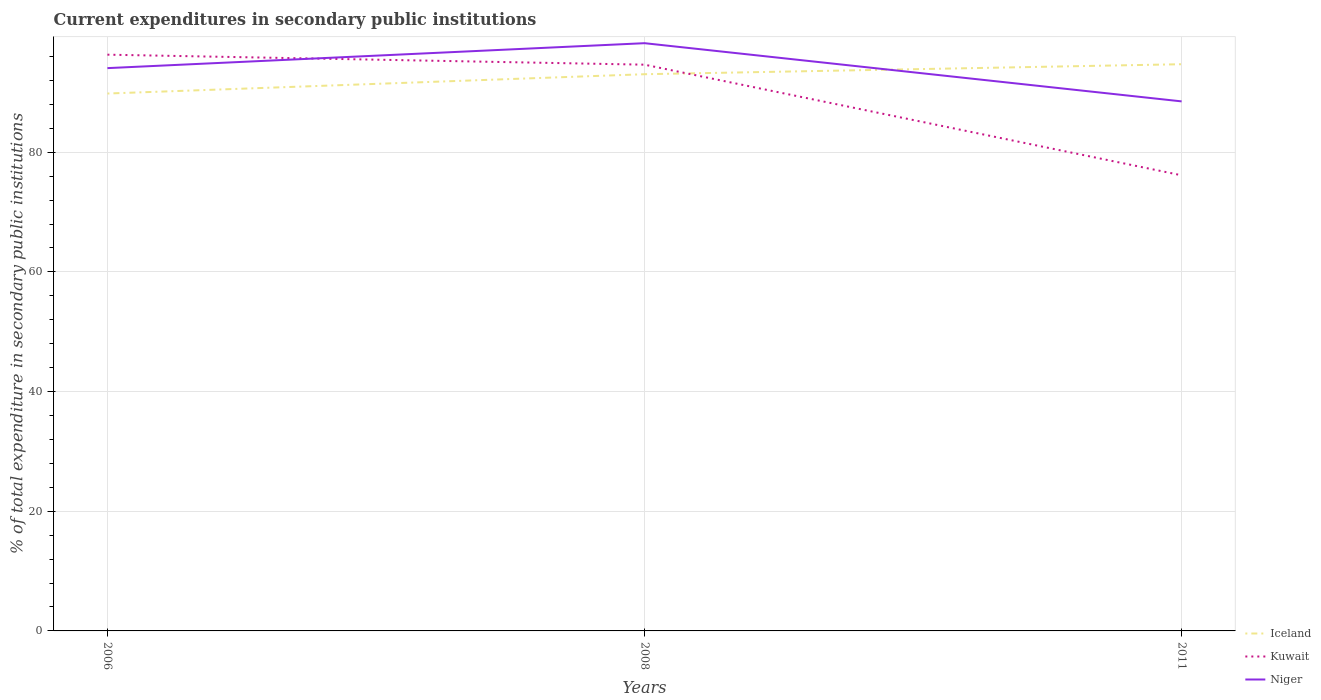Across all years, what is the maximum current expenditures in secondary public institutions in Iceland?
Provide a succinct answer. 89.81. What is the total current expenditures in secondary public institutions in Iceland in the graph?
Keep it short and to the point. -4.9. What is the difference between the highest and the second highest current expenditures in secondary public institutions in Niger?
Keep it short and to the point. 9.73. How many lines are there?
Offer a very short reply. 3. Does the graph contain any zero values?
Give a very brief answer. No. Does the graph contain grids?
Give a very brief answer. Yes. Where does the legend appear in the graph?
Ensure brevity in your answer.  Bottom right. How many legend labels are there?
Your answer should be compact. 3. How are the legend labels stacked?
Your answer should be compact. Vertical. What is the title of the graph?
Keep it short and to the point. Current expenditures in secondary public institutions. What is the label or title of the Y-axis?
Provide a short and direct response. % of total expenditure in secondary public institutions. What is the % of total expenditure in secondary public institutions in Iceland in 2006?
Give a very brief answer. 89.81. What is the % of total expenditure in secondary public institutions of Kuwait in 2006?
Offer a very short reply. 96.3. What is the % of total expenditure in secondary public institutions in Niger in 2006?
Offer a terse response. 94.05. What is the % of total expenditure in secondary public institutions of Iceland in 2008?
Your response must be concise. 93.03. What is the % of total expenditure in secondary public institutions in Kuwait in 2008?
Offer a terse response. 94.63. What is the % of total expenditure in secondary public institutions in Niger in 2008?
Give a very brief answer. 98.22. What is the % of total expenditure in secondary public institutions in Iceland in 2011?
Offer a terse response. 94.7. What is the % of total expenditure in secondary public institutions of Kuwait in 2011?
Your answer should be very brief. 76.14. What is the % of total expenditure in secondary public institutions of Niger in 2011?
Make the answer very short. 88.49. Across all years, what is the maximum % of total expenditure in secondary public institutions in Iceland?
Provide a short and direct response. 94.7. Across all years, what is the maximum % of total expenditure in secondary public institutions in Kuwait?
Ensure brevity in your answer.  96.3. Across all years, what is the maximum % of total expenditure in secondary public institutions of Niger?
Provide a short and direct response. 98.22. Across all years, what is the minimum % of total expenditure in secondary public institutions in Iceland?
Make the answer very short. 89.81. Across all years, what is the minimum % of total expenditure in secondary public institutions in Kuwait?
Your answer should be very brief. 76.14. Across all years, what is the minimum % of total expenditure in secondary public institutions of Niger?
Provide a short and direct response. 88.49. What is the total % of total expenditure in secondary public institutions in Iceland in the graph?
Offer a very short reply. 277.55. What is the total % of total expenditure in secondary public institutions of Kuwait in the graph?
Offer a terse response. 267.07. What is the total % of total expenditure in secondary public institutions in Niger in the graph?
Your answer should be very brief. 280.77. What is the difference between the % of total expenditure in secondary public institutions of Iceland in 2006 and that in 2008?
Keep it short and to the point. -3.23. What is the difference between the % of total expenditure in secondary public institutions in Kuwait in 2006 and that in 2008?
Provide a succinct answer. 1.67. What is the difference between the % of total expenditure in secondary public institutions in Niger in 2006 and that in 2008?
Make the answer very short. -4.17. What is the difference between the % of total expenditure in secondary public institutions in Iceland in 2006 and that in 2011?
Make the answer very short. -4.9. What is the difference between the % of total expenditure in secondary public institutions of Kuwait in 2006 and that in 2011?
Give a very brief answer. 20.16. What is the difference between the % of total expenditure in secondary public institutions in Niger in 2006 and that in 2011?
Keep it short and to the point. 5.56. What is the difference between the % of total expenditure in secondary public institutions in Iceland in 2008 and that in 2011?
Your answer should be very brief. -1.67. What is the difference between the % of total expenditure in secondary public institutions of Kuwait in 2008 and that in 2011?
Your response must be concise. 18.49. What is the difference between the % of total expenditure in secondary public institutions in Niger in 2008 and that in 2011?
Your response must be concise. 9.73. What is the difference between the % of total expenditure in secondary public institutions of Iceland in 2006 and the % of total expenditure in secondary public institutions of Kuwait in 2008?
Your answer should be compact. -4.82. What is the difference between the % of total expenditure in secondary public institutions of Iceland in 2006 and the % of total expenditure in secondary public institutions of Niger in 2008?
Ensure brevity in your answer.  -8.41. What is the difference between the % of total expenditure in secondary public institutions of Kuwait in 2006 and the % of total expenditure in secondary public institutions of Niger in 2008?
Offer a terse response. -1.92. What is the difference between the % of total expenditure in secondary public institutions in Iceland in 2006 and the % of total expenditure in secondary public institutions in Kuwait in 2011?
Your response must be concise. 13.66. What is the difference between the % of total expenditure in secondary public institutions of Iceland in 2006 and the % of total expenditure in secondary public institutions of Niger in 2011?
Provide a succinct answer. 1.31. What is the difference between the % of total expenditure in secondary public institutions of Kuwait in 2006 and the % of total expenditure in secondary public institutions of Niger in 2011?
Ensure brevity in your answer.  7.81. What is the difference between the % of total expenditure in secondary public institutions in Iceland in 2008 and the % of total expenditure in secondary public institutions in Kuwait in 2011?
Your answer should be compact. 16.89. What is the difference between the % of total expenditure in secondary public institutions in Iceland in 2008 and the % of total expenditure in secondary public institutions in Niger in 2011?
Keep it short and to the point. 4.54. What is the difference between the % of total expenditure in secondary public institutions of Kuwait in 2008 and the % of total expenditure in secondary public institutions of Niger in 2011?
Provide a succinct answer. 6.13. What is the average % of total expenditure in secondary public institutions in Iceland per year?
Make the answer very short. 92.52. What is the average % of total expenditure in secondary public institutions of Kuwait per year?
Provide a succinct answer. 89.02. What is the average % of total expenditure in secondary public institutions in Niger per year?
Your answer should be compact. 93.59. In the year 2006, what is the difference between the % of total expenditure in secondary public institutions in Iceland and % of total expenditure in secondary public institutions in Kuwait?
Provide a short and direct response. -6.49. In the year 2006, what is the difference between the % of total expenditure in secondary public institutions of Iceland and % of total expenditure in secondary public institutions of Niger?
Your answer should be very brief. -4.25. In the year 2006, what is the difference between the % of total expenditure in secondary public institutions of Kuwait and % of total expenditure in secondary public institutions of Niger?
Provide a short and direct response. 2.25. In the year 2008, what is the difference between the % of total expenditure in secondary public institutions of Iceland and % of total expenditure in secondary public institutions of Kuwait?
Ensure brevity in your answer.  -1.59. In the year 2008, what is the difference between the % of total expenditure in secondary public institutions of Iceland and % of total expenditure in secondary public institutions of Niger?
Provide a short and direct response. -5.19. In the year 2008, what is the difference between the % of total expenditure in secondary public institutions of Kuwait and % of total expenditure in secondary public institutions of Niger?
Your answer should be very brief. -3.59. In the year 2011, what is the difference between the % of total expenditure in secondary public institutions in Iceland and % of total expenditure in secondary public institutions in Kuwait?
Provide a short and direct response. 18.56. In the year 2011, what is the difference between the % of total expenditure in secondary public institutions in Iceland and % of total expenditure in secondary public institutions in Niger?
Offer a terse response. 6.21. In the year 2011, what is the difference between the % of total expenditure in secondary public institutions of Kuwait and % of total expenditure in secondary public institutions of Niger?
Your response must be concise. -12.35. What is the ratio of the % of total expenditure in secondary public institutions of Iceland in 2006 to that in 2008?
Your answer should be compact. 0.97. What is the ratio of the % of total expenditure in secondary public institutions of Kuwait in 2006 to that in 2008?
Offer a terse response. 1.02. What is the ratio of the % of total expenditure in secondary public institutions in Niger in 2006 to that in 2008?
Ensure brevity in your answer.  0.96. What is the ratio of the % of total expenditure in secondary public institutions of Iceland in 2006 to that in 2011?
Provide a succinct answer. 0.95. What is the ratio of the % of total expenditure in secondary public institutions of Kuwait in 2006 to that in 2011?
Ensure brevity in your answer.  1.26. What is the ratio of the % of total expenditure in secondary public institutions in Niger in 2006 to that in 2011?
Your answer should be very brief. 1.06. What is the ratio of the % of total expenditure in secondary public institutions in Iceland in 2008 to that in 2011?
Your answer should be compact. 0.98. What is the ratio of the % of total expenditure in secondary public institutions of Kuwait in 2008 to that in 2011?
Make the answer very short. 1.24. What is the ratio of the % of total expenditure in secondary public institutions of Niger in 2008 to that in 2011?
Your response must be concise. 1.11. What is the difference between the highest and the second highest % of total expenditure in secondary public institutions of Iceland?
Provide a short and direct response. 1.67. What is the difference between the highest and the second highest % of total expenditure in secondary public institutions in Kuwait?
Offer a terse response. 1.67. What is the difference between the highest and the second highest % of total expenditure in secondary public institutions of Niger?
Your answer should be very brief. 4.17. What is the difference between the highest and the lowest % of total expenditure in secondary public institutions of Iceland?
Your answer should be very brief. 4.9. What is the difference between the highest and the lowest % of total expenditure in secondary public institutions of Kuwait?
Your answer should be very brief. 20.16. What is the difference between the highest and the lowest % of total expenditure in secondary public institutions in Niger?
Provide a short and direct response. 9.73. 